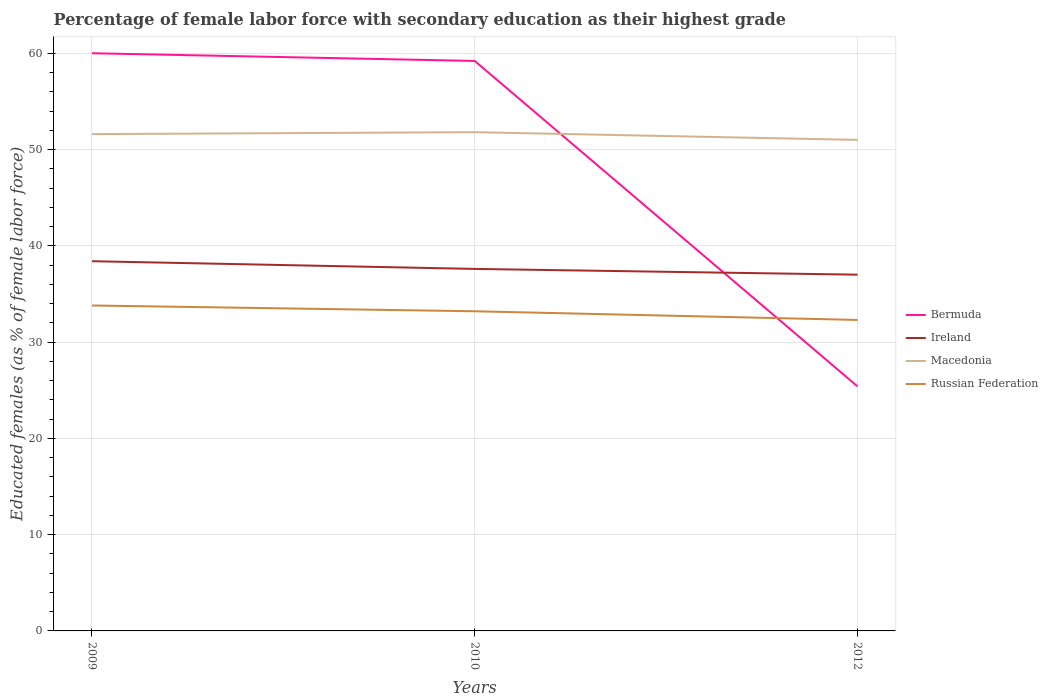Is the number of lines equal to the number of legend labels?
Your response must be concise. Yes. Across all years, what is the maximum percentage of female labor force with secondary education in Bermuda?
Give a very brief answer. 25.4. What is the total percentage of female labor force with secondary education in Russian Federation in the graph?
Make the answer very short. 0.6. What is the difference between the highest and the second highest percentage of female labor force with secondary education in Bermuda?
Make the answer very short. 34.6. What is the difference between the highest and the lowest percentage of female labor force with secondary education in Bermuda?
Provide a short and direct response. 2. How many lines are there?
Offer a terse response. 4. How many years are there in the graph?
Make the answer very short. 3. Does the graph contain any zero values?
Make the answer very short. No. Where does the legend appear in the graph?
Provide a short and direct response. Center right. What is the title of the graph?
Keep it short and to the point. Percentage of female labor force with secondary education as their highest grade. Does "Tanzania" appear as one of the legend labels in the graph?
Give a very brief answer. No. What is the label or title of the X-axis?
Ensure brevity in your answer.  Years. What is the label or title of the Y-axis?
Your answer should be very brief. Educated females (as % of female labor force). What is the Educated females (as % of female labor force) of Ireland in 2009?
Your response must be concise. 38.4. What is the Educated females (as % of female labor force) in Macedonia in 2009?
Your answer should be compact. 51.6. What is the Educated females (as % of female labor force) in Russian Federation in 2009?
Provide a short and direct response. 33.8. What is the Educated females (as % of female labor force) of Bermuda in 2010?
Your answer should be very brief. 59.2. What is the Educated females (as % of female labor force) of Ireland in 2010?
Ensure brevity in your answer.  37.6. What is the Educated females (as % of female labor force) in Macedonia in 2010?
Provide a succinct answer. 51.8. What is the Educated females (as % of female labor force) in Russian Federation in 2010?
Offer a very short reply. 33.2. What is the Educated females (as % of female labor force) in Bermuda in 2012?
Your answer should be very brief. 25.4. What is the Educated females (as % of female labor force) of Ireland in 2012?
Your answer should be compact. 37. What is the Educated females (as % of female labor force) in Russian Federation in 2012?
Make the answer very short. 32.3. Across all years, what is the maximum Educated females (as % of female labor force) of Ireland?
Provide a succinct answer. 38.4. Across all years, what is the maximum Educated females (as % of female labor force) of Macedonia?
Provide a short and direct response. 51.8. Across all years, what is the maximum Educated females (as % of female labor force) of Russian Federation?
Offer a terse response. 33.8. Across all years, what is the minimum Educated females (as % of female labor force) of Bermuda?
Offer a very short reply. 25.4. Across all years, what is the minimum Educated females (as % of female labor force) in Ireland?
Your answer should be compact. 37. Across all years, what is the minimum Educated females (as % of female labor force) in Macedonia?
Give a very brief answer. 51. Across all years, what is the minimum Educated females (as % of female labor force) of Russian Federation?
Give a very brief answer. 32.3. What is the total Educated females (as % of female labor force) in Bermuda in the graph?
Your answer should be compact. 144.6. What is the total Educated females (as % of female labor force) in Ireland in the graph?
Your answer should be very brief. 113. What is the total Educated females (as % of female labor force) in Macedonia in the graph?
Make the answer very short. 154.4. What is the total Educated females (as % of female labor force) in Russian Federation in the graph?
Ensure brevity in your answer.  99.3. What is the difference between the Educated females (as % of female labor force) of Bermuda in 2009 and that in 2010?
Offer a terse response. 0.8. What is the difference between the Educated females (as % of female labor force) in Macedonia in 2009 and that in 2010?
Your answer should be very brief. -0.2. What is the difference between the Educated females (as % of female labor force) of Bermuda in 2009 and that in 2012?
Your answer should be compact. 34.6. What is the difference between the Educated females (as % of female labor force) in Bermuda in 2010 and that in 2012?
Your answer should be compact. 33.8. What is the difference between the Educated females (as % of female labor force) in Ireland in 2010 and that in 2012?
Your response must be concise. 0.6. What is the difference between the Educated females (as % of female labor force) in Bermuda in 2009 and the Educated females (as % of female labor force) in Ireland in 2010?
Keep it short and to the point. 22.4. What is the difference between the Educated females (as % of female labor force) of Bermuda in 2009 and the Educated females (as % of female labor force) of Russian Federation in 2010?
Your answer should be compact. 26.8. What is the difference between the Educated females (as % of female labor force) of Macedonia in 2009 and the Educated females (as % of female labor force) of Russian Federation in 2010?
Give a very brief answer. 18.4. What is the difference between the Educated females (as % of female labor force) in Bermuda in 2009 and the Educated females (as % of female labor force) in Ireland in 2012?
Give a very brief answer. 23. What is the difference between the Educated females (as % of female labor force) in Bermuda in 2009 and the Educated females (as % of female labor force) in Macedonia in 2012?
Keep it short and to the point. 9. What is the difference between the Educated females (as % of female labor force) of Bermuda in 2009 and the Educated females (as % of female labor force) of Russian Federation in 2012?
Keep it short and to the point. 27.7. What is the difference between the Educated females (as % of female labor force) of Ireland in 2009 and the Educated females (as % of female labor force) of Macedonia in 2012?
Offer a terse response. -12.6. What is the difference between the Educated females (as % of female labor force) of Ireland in 2009 and the Educated females (as % of female labor force) of Russian Federation in 2012?
Offer a terse response. 6.1. What is the difference between the Educated females (as % of female labor force) of Macedonia in 2009 and the Educated females (as % of female labor force) of Russian Federation in 2012?
Make the answer very short. 19.3. What is the difference between the Educated females (as % of female labor force) of Bermuda in 2010 and the Educated females (as % of female labor force) of Ireland in 2012?
Offer a very short reply. 22.2. What is the difference between the Educated females (as % of female labor force) of Bermuda in 2010 and the Educated females (as % of female labor force) of Macedonia in 2012?
Provide a short and direct response. 8.2. What is the difference between the Educated females (as % of female labor force) of Bermuda in 2010 and the Educated females (as % of female labor force) of Russian Federation in 2012?
Provide a succinct answer. 26.9. What is the difference between the Educated females (as % of female labor force) of Ireland in 2010 and the Educated females (as % of female labor force) of Macedonia in 2012?
Keep it short and to the point. -13.4. What is the difference between the Educated females (as % of female labor force) of Ireland in 2010 and the Educated females (as % of female labor force) of Russian Federation in 2012?
Your response must be concise. 5.3. What is the difference between the Educated females (as % of female labor force) in Macedonia in 2010 and the Educated females (as % of female labor force) in Russian Federation in 2012?
Your answer should be very brief. 19.5. What is the average Educated females (as % of female labor force) in Bermuda per year?
Give a very brief answer. 48.2. What is the average Educated females (as % of female labor force) in Ireland per year?
Your answer should be compact. 37.67. What is the average Educated females (as % of female labor force) of Macedonia per year?
Offer a very short reply. 51.47. What is the average Educated females (as % of female labor force) of Russian Federation per year?
Provide a short and direct response. 33.1. In the year 2009, what is the difference between the Educated females (as % of female labor force) in Bermuda and Educated females (as % of female labor force) in Ireland?
Offer a terse response. 21.6. In the year 2009, what is the difference between the Educated females (as % of female labor force) of Bermuda and Educated females (as % of female labor force) of Russian Federation?
Your answer should be compact. 26.2. In the year 2009, what is the difference between the Educated females (as % of female labor force) of Ireland and Educated females (as % of female labor force) of Russian Federation?
Keep it short and to the point. 4.6. In the year 2009, what is the difference between the Educated females (as % of female labor force) in Macedonia and Educated females (as % of female labor force) in Russian Federation?
Ensure brevity in your answer.  17.8. In the year 2010, what is the difference between the Educated females (as % of female labor force) of Bermuda and Educated females (as % of female labor force) of Ireland?
Your answer should be compact. 21.6. In the year 2010, what is the difference between the Educated females (as % of female labor force) in Bermuda and Educated females (as % of female labor force) in Macedonia?
Your response must be concise. 7.4. In the year 2010, what is the difference between the Educated females (as % of female labor force) of Bermuda and Educated females (as % of female labor force) of Russian Federation?
Your answer should be compact. 26. In the year 2012, what is the difference between the Educated females (as % of female labor force) in Bermuda and Educated females (as % of female labor force) in Macedonia?
Provide a succinct answer. -25.6. In the year 2012, what is the difference between the Educated females (as % of female labor force) in Ireland and Educated females (as % of female labor force) in Russian Federation?
Your answer should be compact. 4.7. What is the ratio of the Educated females (as % of female labor force) of Bermuda in 2009 to that in 2010?
Your answer should be very brief. 1.01. What is the ratio of the Educated females (as % of female labor force) in Ireland in 2009 to that in 2010?
Offer a terse response. 1.02. What is the ratio of the Educated females (as % of female labor force) in Russian Federation in 2009 to that in 2010?
Provide a short and direct response. 1.02. What is the ratio of the Educated females (as % of female labor force) of Bermuda in 2009 to that in 2012?
Keep it short and to the point. 2.36. What is the ratio of the Educated females (as % of female labor force) of Ireland in 2009 to that in 2012?
Ensure brevity in your answer.  1.04. What is the ratio of the Educated females (as % of female labor force) of Macedonia in 2009 to that in 2012?
Offer a terse response. 1.01. What is the ratio of the Educated females (as % of female labor force) of Russian Federation in 2009 to that in 2012?
Offer a very short reply. 1.05. What is the ratio of the Educated females (as % of female labor force) in Bermuda in 2010 to that in 2012?
Give a very brief answer. 2.33. What is the ratio of the Educated females (as % of female labor force) of Ireland in 2010 to that in 2012?
Give a very brief answer. 1.02. What is the ratio of the Educated females (as % of female labor force) of Macedonia in 2010 to that in 2012?
Your answer should be very brief. 1.02. What is the ratio of the Educated females (as % of female labor force) in Russian Federation in 2010 to that in 2012?
Your response must be concise. 1.03. What is the difference between the highest and the second highest Educated females (as % of female labor force) of Ireland?
Provide a succinct answer. 0.8. What is the difference between the highest and the lowest Educated females (as % of female labor force) in Bermuda?
Ensure brevity in your answer.  34.6. What is the difference between the highest and the lowest Educated females (as % of female labor force) in Ireland?
Ensure brevity in your answer.  1.4. What is the difference between the highest and the lowest Educated females (as % of female labor force) of Russian Federation?
Keep it short and to the point. 1.5. 